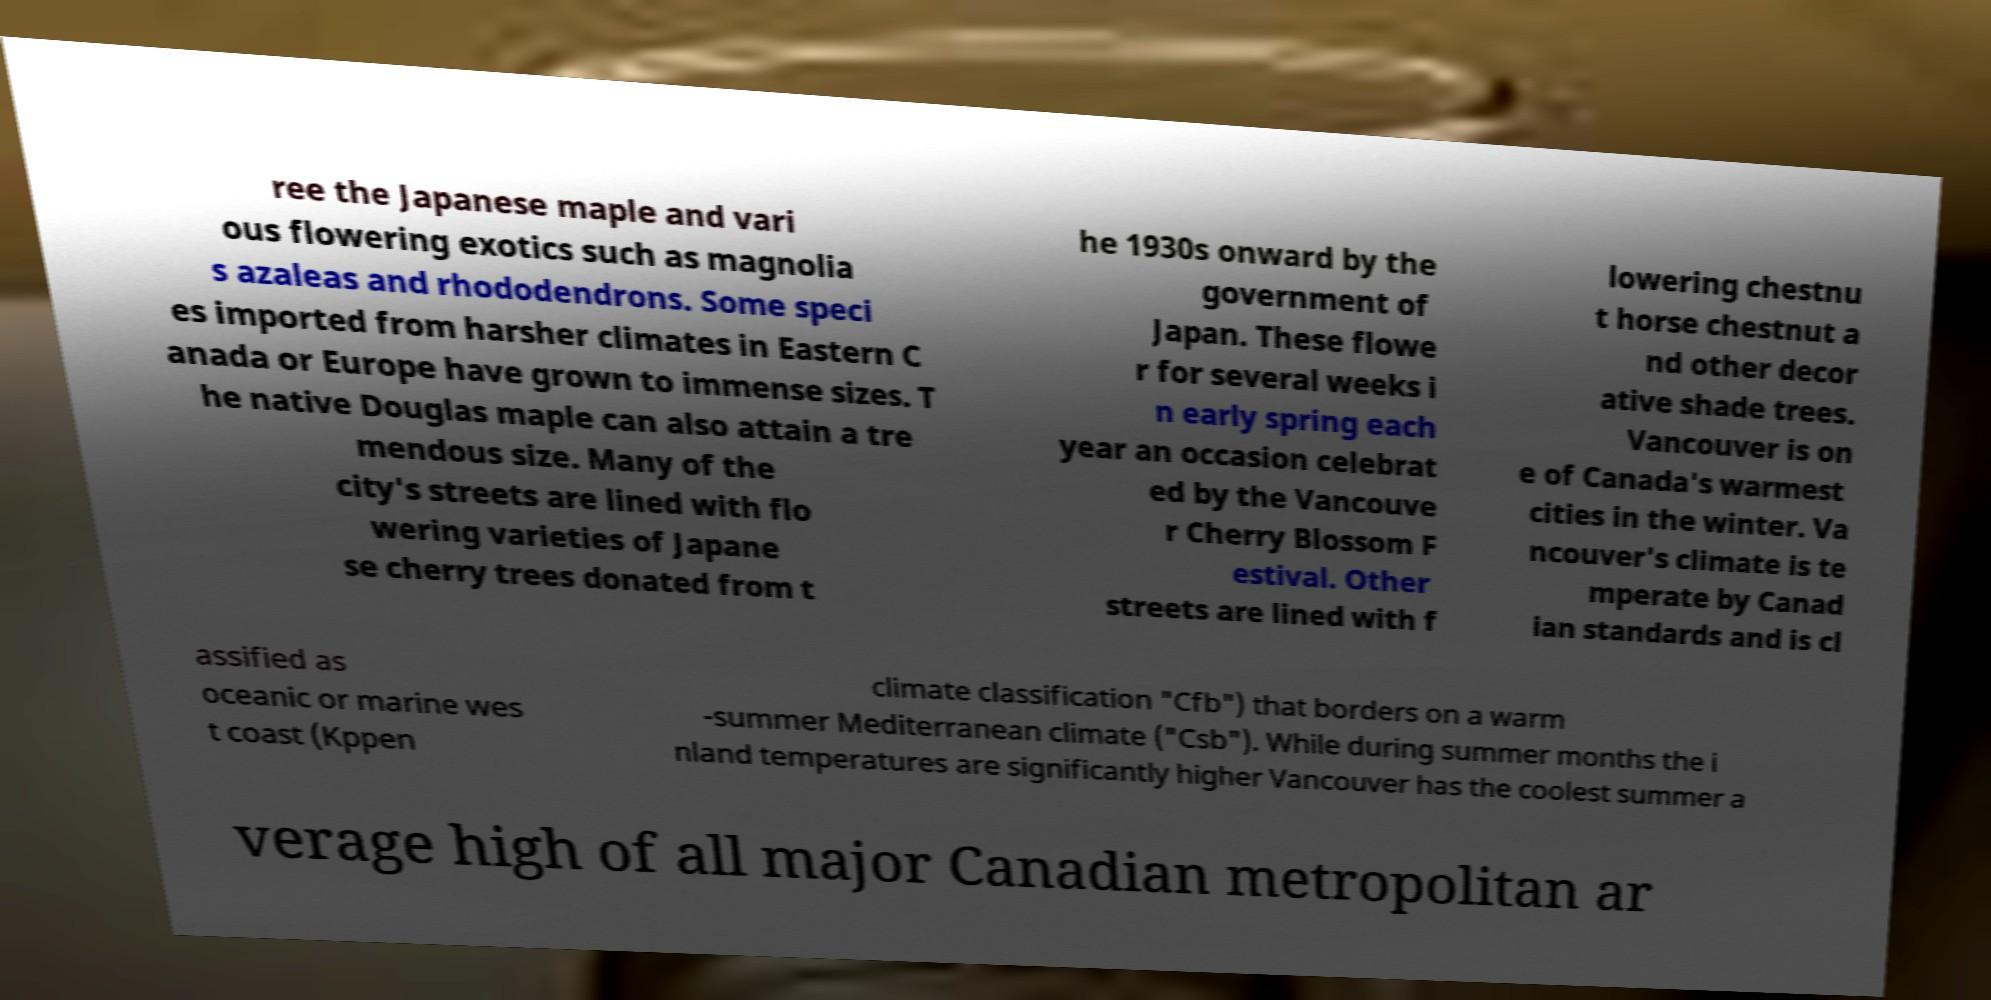Could you extract and type out the text from this image? ree the Japanese maple and vari ous flowering exotics such as magnolia s azaleas and rhododendrons. Some speci es imported from harsher climates in Eastern C anada or Europe have grown to immense sizes. T he native Douglas maple can also attain a tre mendous size. Many of the city's streets are lined with flo wering varieties of Japane se cherry trees donated from t he 1930s onward by the government of Japan. These flowe r for several weeks i n early spring each year an occasion celebrat ed by the Vancouve r Cherry Blossom F estival. Other streets are lined with f lowering chestnu t horse chestnut a nd other decor ative shade trees. Vancouver is on e of Canada's warmest cities in the winter. Va ncouver's climate is te mperate by Canad ian standards and is cl assified as oceanic or marine wes t coast (Kppen climate classification "Cfb") that borders on a warm -summer Mediterranean climate ("Csb"). While during summer months the i nland temperatures are significantly higher Vancouver has the coolest summer a verage high of all major Canadian metropolitan ar 